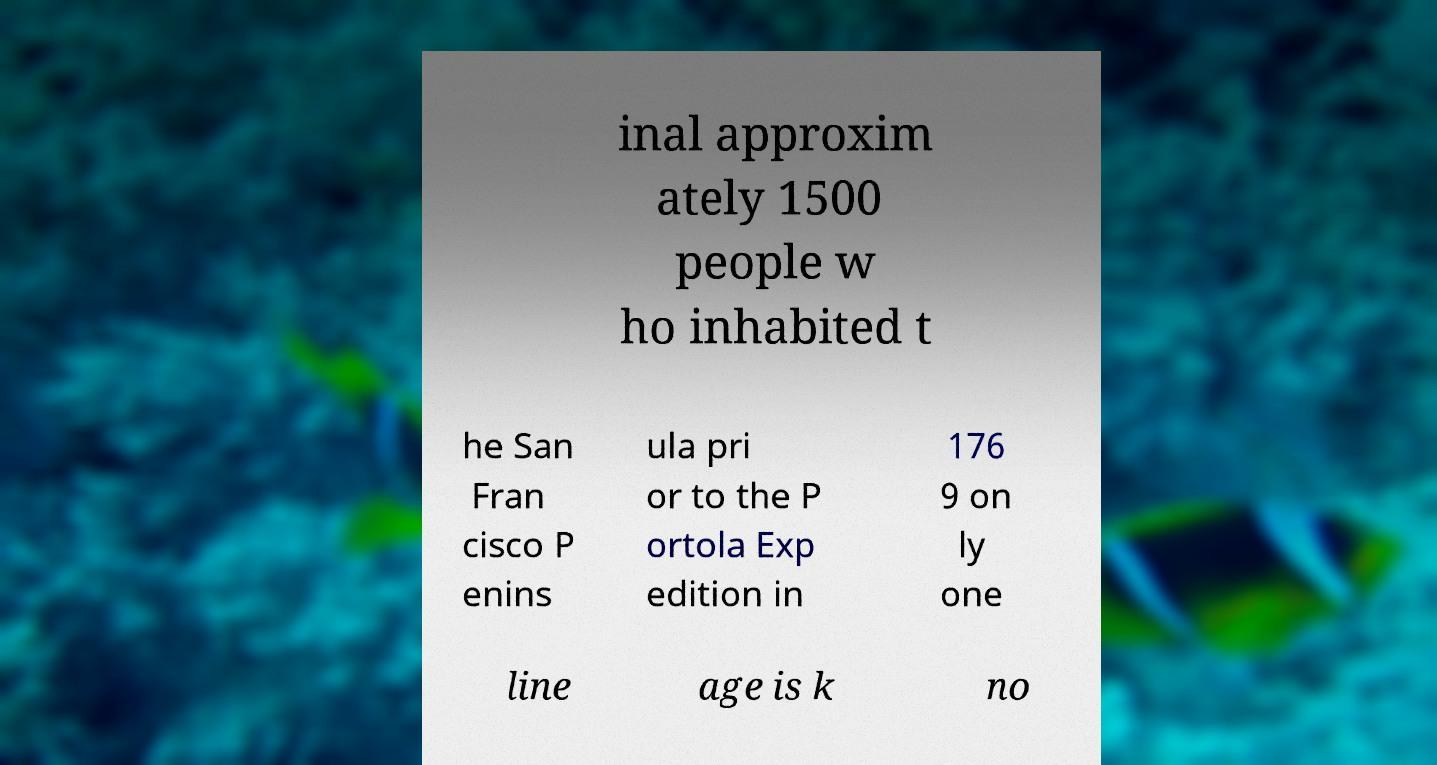For documentation purposes, I need the text within this image transcribed. Could you provide that? inal approxim ately 1500 people w ho inhabited t he San Fran cisco P enins ula pri or to the P ortola Exp edition in 176 9 on ly one line age is k no 